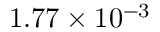Convert formula to latex. <formula><loc_0><loc_0><loc_500><loc_500>1 . 7 7 \times 1 0 ^ { - 3 }</formula> 